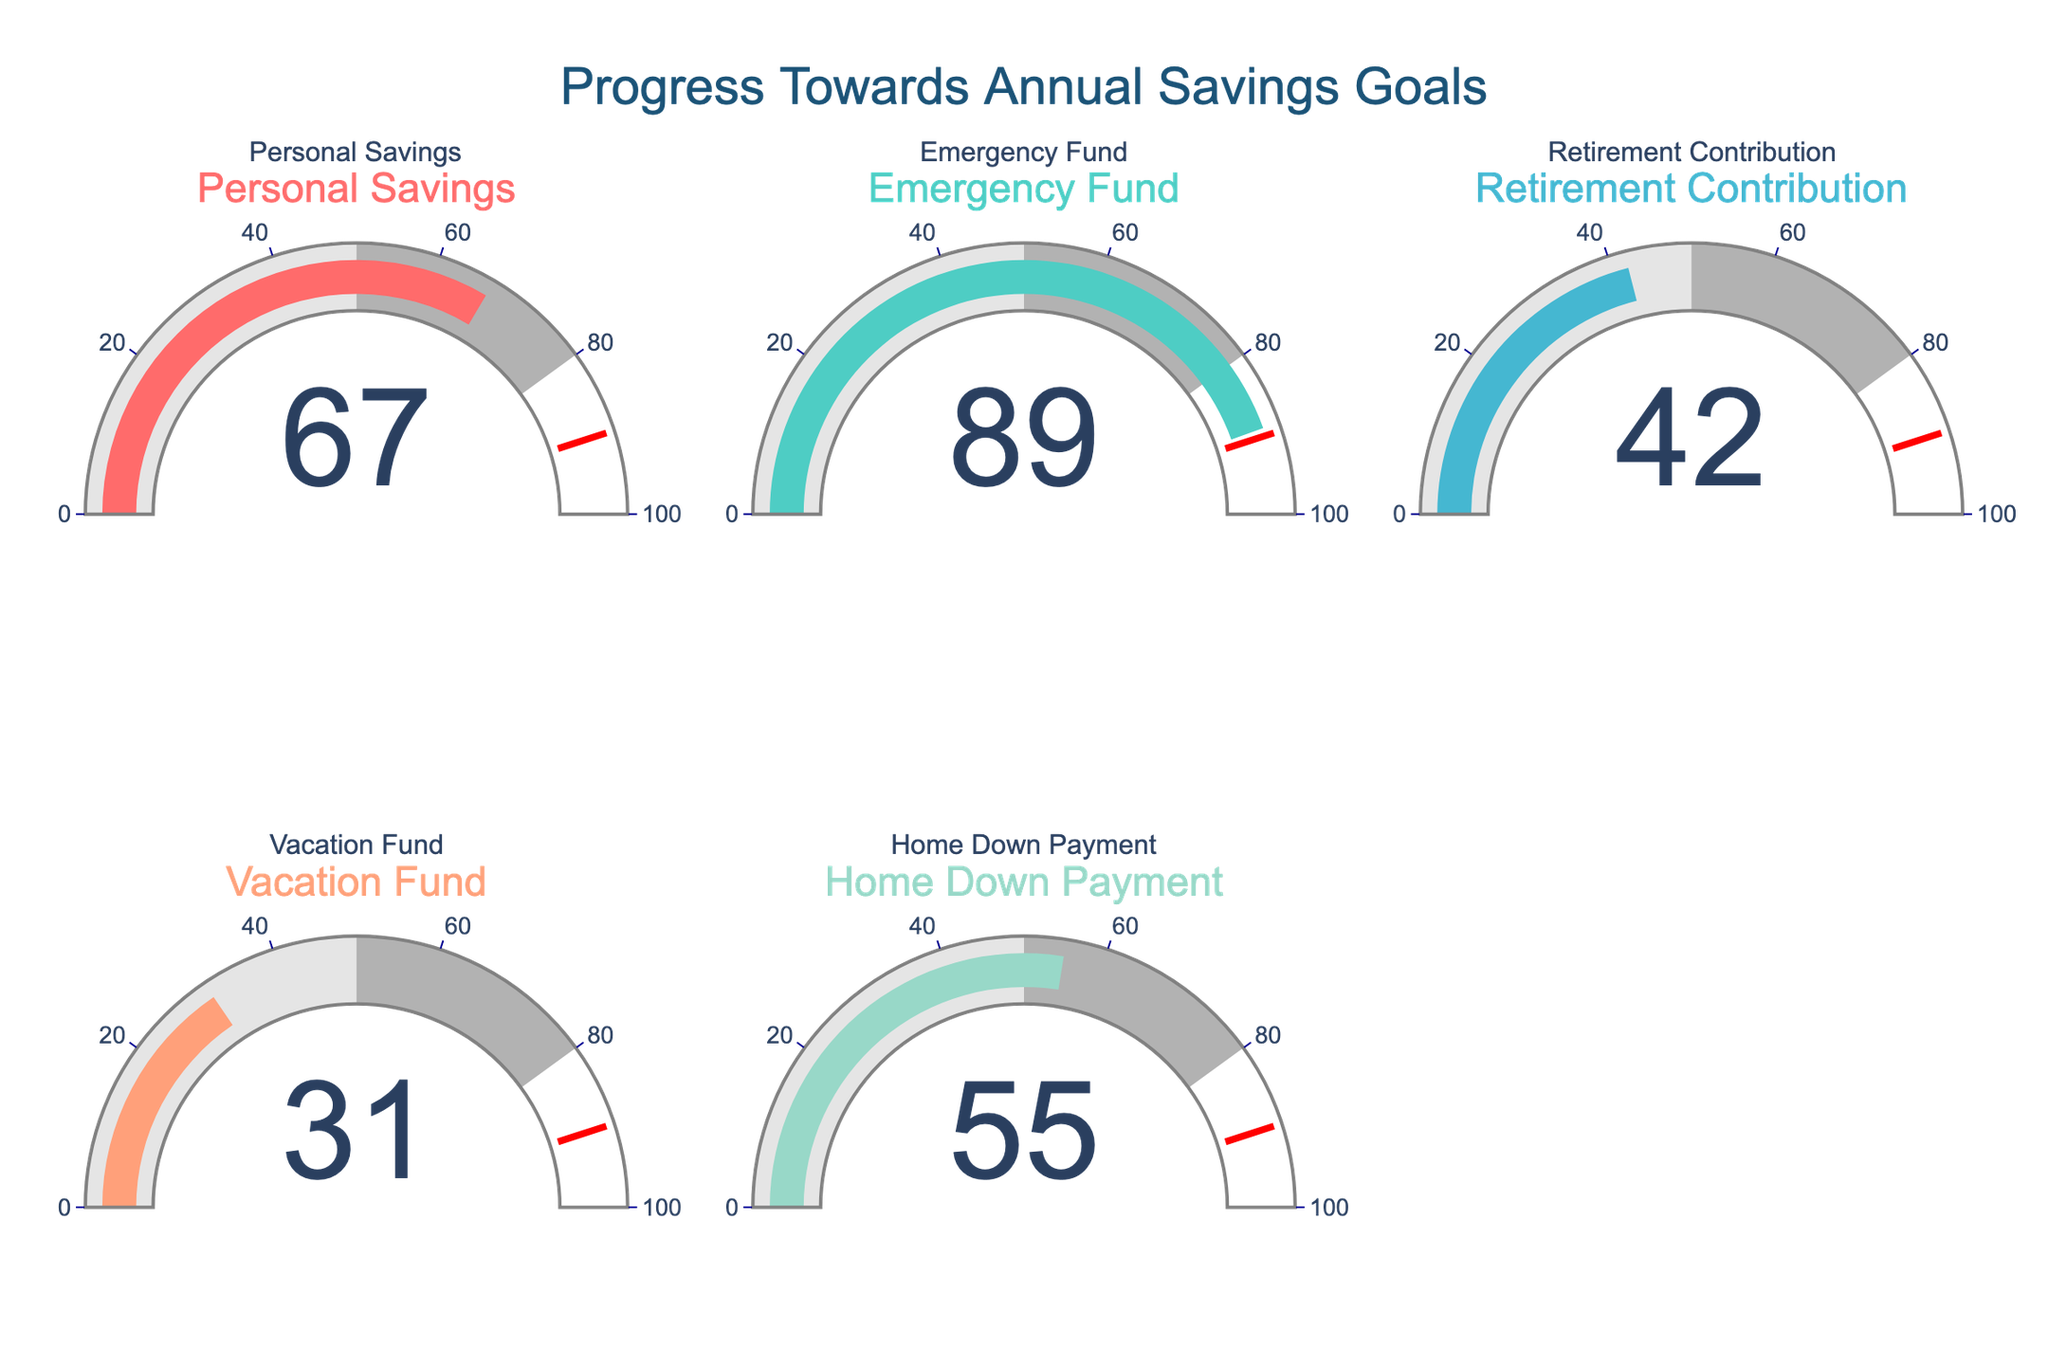Which category shows the highest progress towards the annual savings goal? By looking at the gauge charts, identify the gauge with the highest value. The Emergency Fund gauge has the highest value at 89%.
Answer: Emergency Fund What is the progress percentage for the Personal Savings category? Refer to the number displayed on the gauge chart for Personal Savings. The value displayed is 67%.
Answer: 67% How many categories are displayed in the figure? Count the number of gauge charts in the figure. There are five gauge charts corresponding to Personal Savings, Emergency Fund, Retirement Contribution, Vacation Fund, and Home Down Payment.
Answer: 5 What is the difference in progress between the Retirement Contribution and the Vacation Fund? Subtract the progress percentage of the Vacation Fund from that of the Retirement Contribution. The Retirement Contribution is at 42%, and the Vacation Fund is at 31%. The difference is 42 - 31 = 11%.
Answer: 11% Which category has the second-highest progress towards its goal? Compare the progress percentages for all categories and determine the second highest. The Emergency Fund has the highest at 89%, and Personal Savings has the second-highest at 67%.
Answer: Personal Savings What is the average progress percentage across all categories? Sum all the progress percentages and divide by the total number of categories. The sum is 67 + 89 + 42 + 31 + 55 = 284, and there are 5 categories. The average is 284 / 5 = 56.8%.
Answer: 56.8% Is any category below 40% progress? Check each gauge chart and identify if any progress percentage is less than 40%. Both the Retirement Contribution (42%) and the Vacation Fund (31%) exhibit values to compare. Only the Vacation Fund is below 40% at 31%.
Answer: Yes Which categories are above the 50% threshold? Identify all gauge charts with progress percentages above 50%. The categories with progress above 50% are Personal Savings (67%), Emergency Fund (89%), and Home Down Payment (55%).
Answer: Personal Savings, Emergency Fund, Home Down Payment How much more progress does the Emergency Fund need to reach 100%? Subtract the current progress of the Emergency Fund from 100%. The progress of the Emergency Fund is 89%, so it needs 100 - 89 = 11% more to reach 100%.
Answer: 11% 